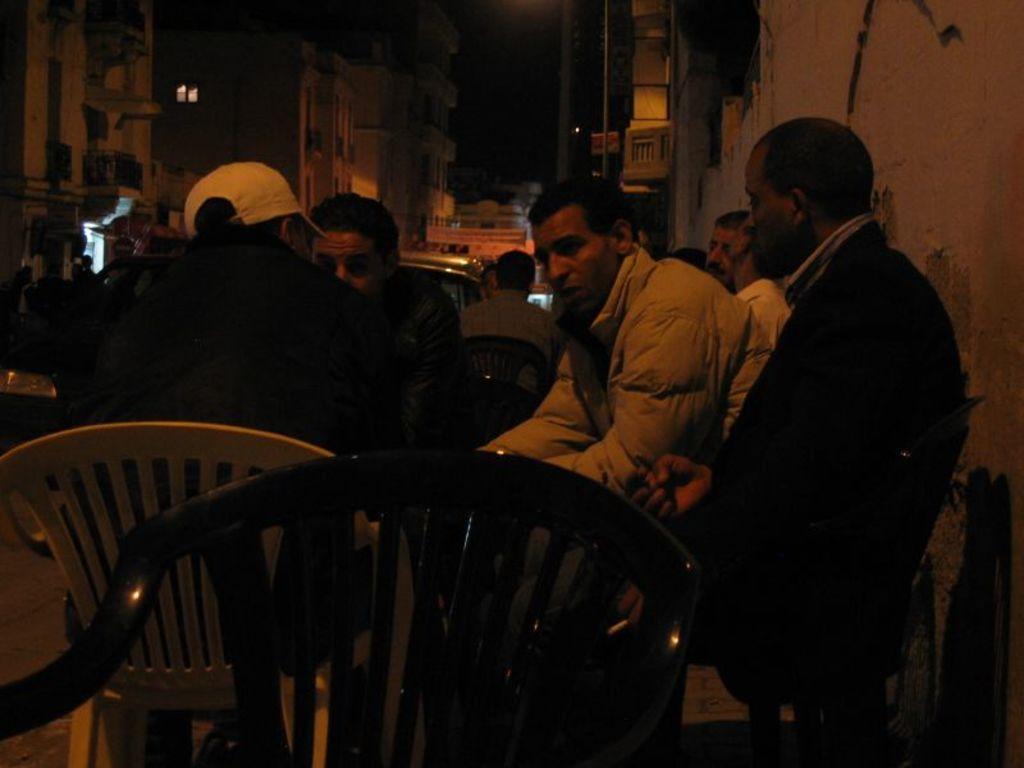Can you describe this image briefly? In this picture there are four people sitting in a table. The picture is clicked on a road. There are vehicles in the background and buildings. 